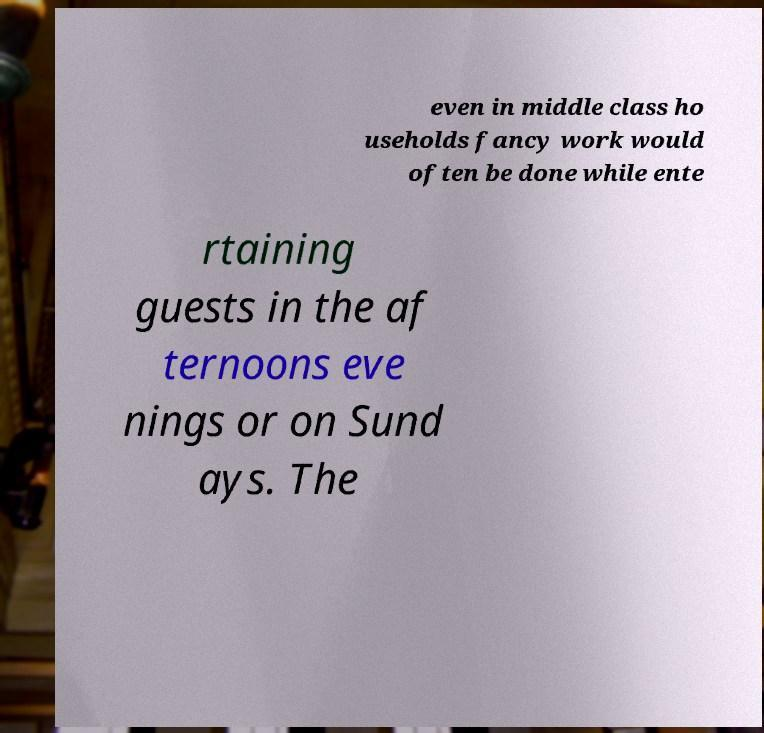Can you accurately transcribe the text from the provided image for me? even in middle class ho useholds fancy work would often be done while ente rtaining guests in the af ternoons eve nings or on Sund ays. The 